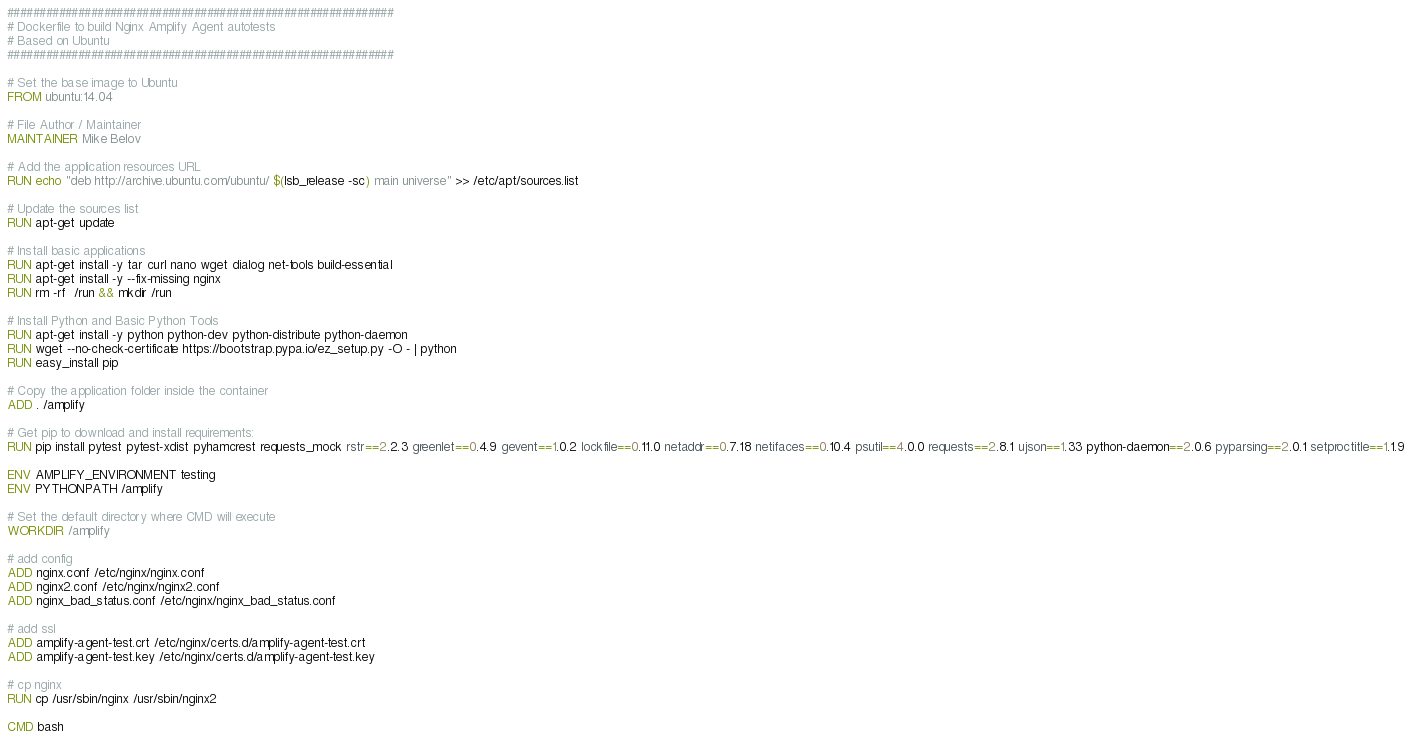Convert code to text. <code><loc_0><loc_0><loc_500><loc_500><_Dockerfile_>############################################################
# Dockerfile to build Nginx Amplify Agent autotests
# Based on Ubuntu
############################################################

# Set the base image to Ubuntu
FROM ubuntu:14.04

# File Author / Maintainer
MAINTAINER Mike Belov

# Add the application resources URL
RUN echo "deb http://archive.ubuntu.com/ubuntu/ $(lsb_release -sc) main universe" >> /etc/apt/sources.list

# Update the sources list
RUN apt-get update

# Install basic applications
RUN apt-get install -y tar curl nano wget dialog net-tools build-essential
RUN apt-get install -y --fix-missing nginx
RUN rm -rf  /run && mkdir /run

# Install Python and Basic Python Tools
RUN apt-get install -y python python-dev python-distribute python-daemon
RUN wget --no-check-certificate https://bootstrap.pypa.io/ez_setup.py -O - | python
RUN easy_install pip

# Copy the application folder inside the container
ADD . /amplify

# Get pip to download and install requirements:
RUN pip install pytest pytest-xdist pyhamcrest requests_mock rstr==2.2.3 greenlet==0.4.9 gevent==1.0.2 lockfile==0.11.0 netaddr==0.7.18 netifaces==0.10.4 psutil==4.0.0 requests==2.8.1 ujson==1.33 python-daemon==2.0.6 pyparsing==2.0.1 setproctitle==1.1.9

ENV AMPLIFY_ENVIRONMENT testing
ENV PYTHONPATH /amplify

# Set the default directory where CMD will execute
WORKDIR /amplify

# add config
ADD nginx.conf /etc/nginx/nginx.conf
ADD nginx2.conf /etc/nginx/nginx2.conf
ADD nginx_bad_status.conf /etc/nginx/nginx_bad_status.conf

# add ssl
ADD amplify-agent-test.crt /etc/nginx/certs.d/amplify-agent-test.crt
ADD amplify-agent-test.key /etc/nginx/certs.d/amplify-agent-test.key

# cp nginx
RUN cp /usr/sbin/nginx /usr/sbin/nginx2

CMD bash</code> 